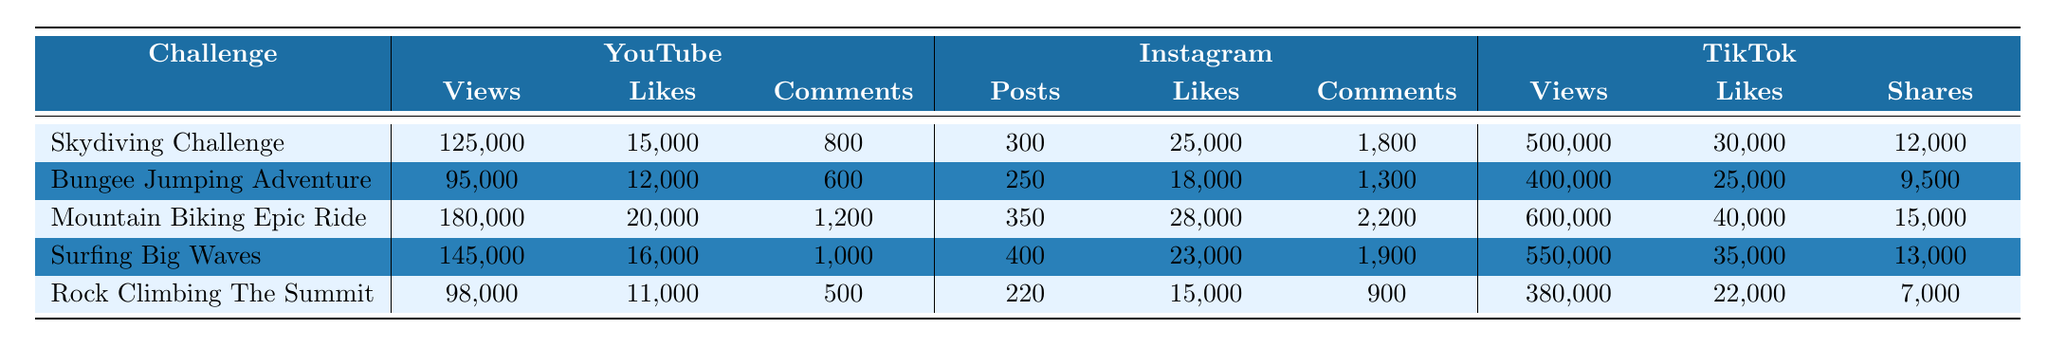What video had the highest views on YouTube? The table shows that the "Mountain Biking Epic Ride" has the highest views on YouTube with a total of 180,000 views.
Answer: Mountain Biking Epic Ride What is the difference in likes between the "Surfing Big Waves" and "Rock Climbing The Summit" videos on YouTube? The likes for "Surfing Big Waves" are 16,000 and for "Rock Climbing The Summit" are 11,000. The difference is 16,000 - 11,000 = 5,000 likes.
Answer: 5,000 likes Which Instagram video received the least comments? By comparing the comment counts on Instagram, "Rock Climbing The Summit" has the least with 900 comments.
Answer: Rock Climbing The Summit What is the total number of views for all TikTok videos? The total views can be calculated by adding all views: 500,000 + 400,000 + 600,000 + 550,000 + 380,000 = 2,480,000 views.
Answer: 2,480,000 views True or False: The "Bungee Jumping Adventure" has more likes on TikTok than on Instagram. On TikTok, it has 25,000 likes, while on Instagram it has 18,000 likes. Since 25,000 > 18,000, the statement is true.
Answer: True Which video has the highest number of shares on TikTok? Looking at the shares column for TikTok, "Mountain Biking Epic Ride" stands out with 15,000 shares, which is the highest.
Answer: Mountain Biking Epic Ride What percentage of views does the "Skydiving Challenge" have compared to the total views on TikTok? The views for "Skydiving Challenge" are 500,000. The total views for TikTok are 2,480,000. The percentage is (500,000 / 2,480,000) * 100 ≈ 20.16%.
Answer: ≈ 20.16% What is the average number of likes received by the videos on Instagram? To find the average likes on Instagram, sum the likes and divide by the number of videos: (25,000 + 18,000 + 28,000 + 23,000 + 15,000) / 5 = 21,800 likes.
Answer: 21,800 likes Which extreme sports challenge had the highest engagement rate (likes per view) on YouTube? Calculate the engagement rate by dividing likes by views for each video on YouTube: "Skydiving Challenge" (15,000 / 125,000 = 0.12), "Bungee Jumping Adventure" (12,000 / 95,000 = 0.126), "Mountain Biking Epic Ride" (20,000 / 180,000 = 0.111), "Surfing Big Waves" (16,000 / 145,000 = 0.110), and "Rock Climbing The Summit" (11,000 / 98,000 ≈ 0.112). The highest engagement rate is for "Bungee Jumping Adventure."
Answer: Bungee Jumping Adventure How does the total comments on YouTube compare to the total likes on TikTok? Total YouTube comments = 800 + 600 + 1,200 + 1,000 + 500 = 4,100. Total TikTok likes = 30,000 + 25,000 + 40,000 + 35,000 + 22,000 = 152,000. 4,100 is significantly less than 152,000 likes.
Answer: It is significantly lower 